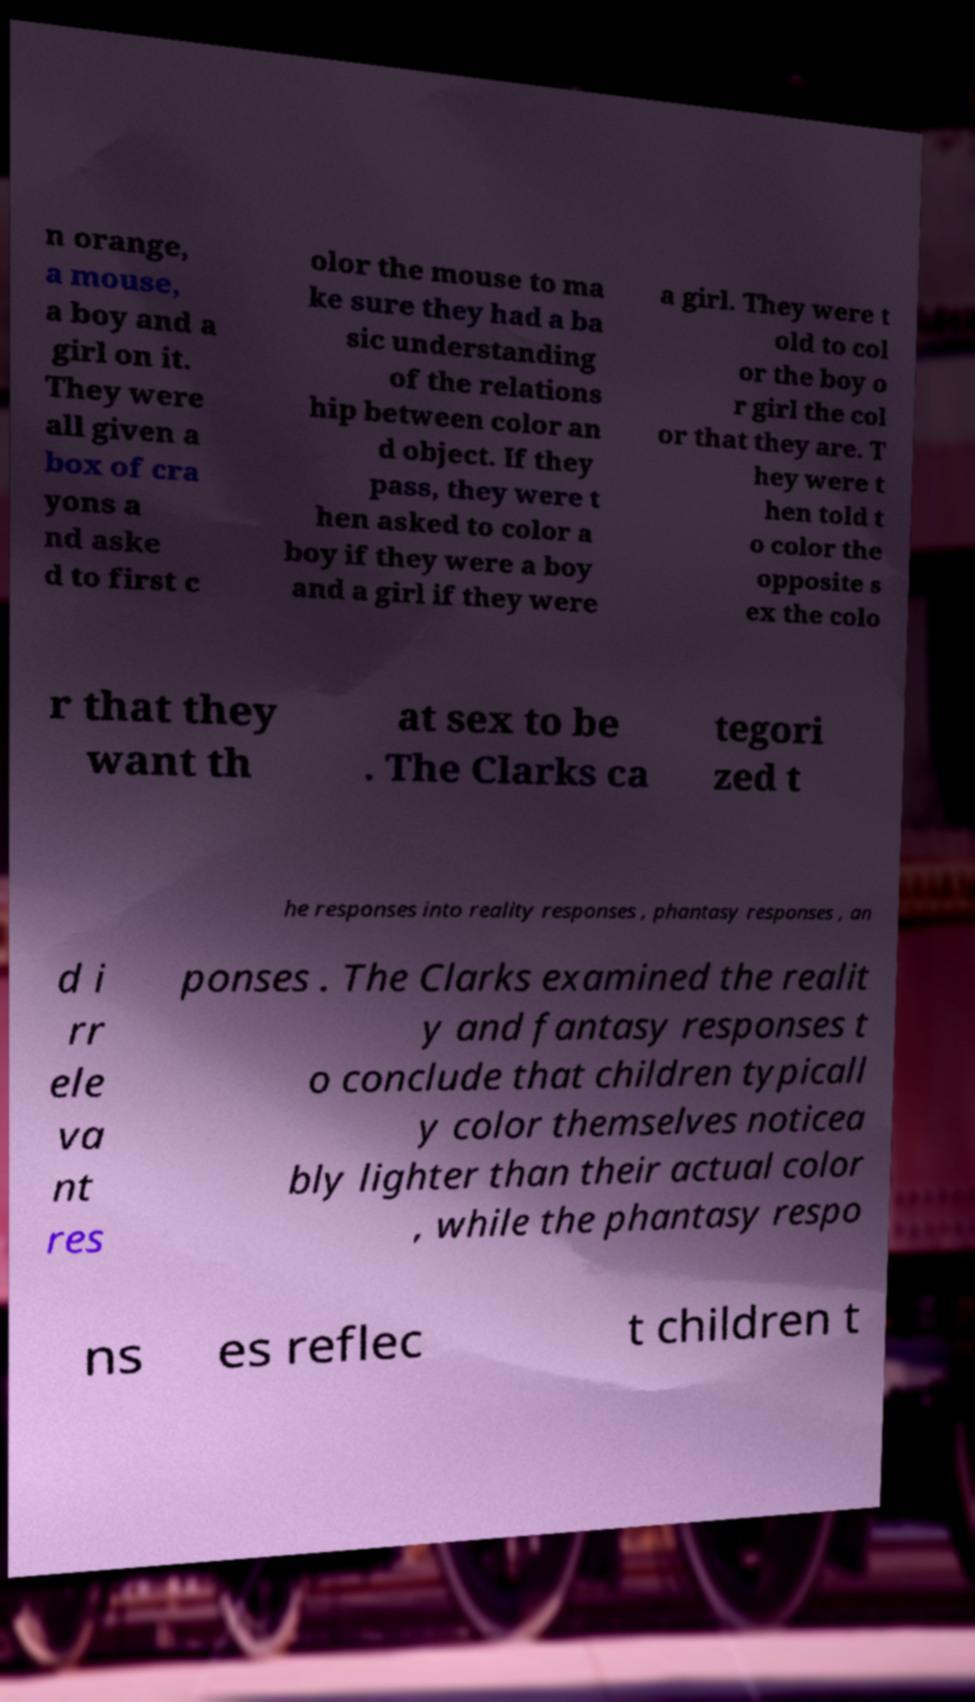Could you assist in decoding the text presented in this image and type it out clearly? n orange, a mouse, a boy and a girl on it. They were all given a box of cra yons a nd aske d to first c olor the mouse to ma ke sure they had a ba sic understanding of the relations hip between color an d object. If they pass, they were t hen asked to color a boy if they were a boy and a girl if they were a girl. They were t old to col or the boy o r girl the col or that they are. T hey were t hen told t o color the opposite s ex the colo r that they want th at sex to be . The Clarks ca tegori zed t he responses into reality responses , phantasy responses , an d i rr ele va nt res ponses . The Clarks examined the realit y and fantasy responses t o conclude that children typicall y color themselves noticea bly lighter than their actual color , while the phantasy respo ns es reflec t children t 